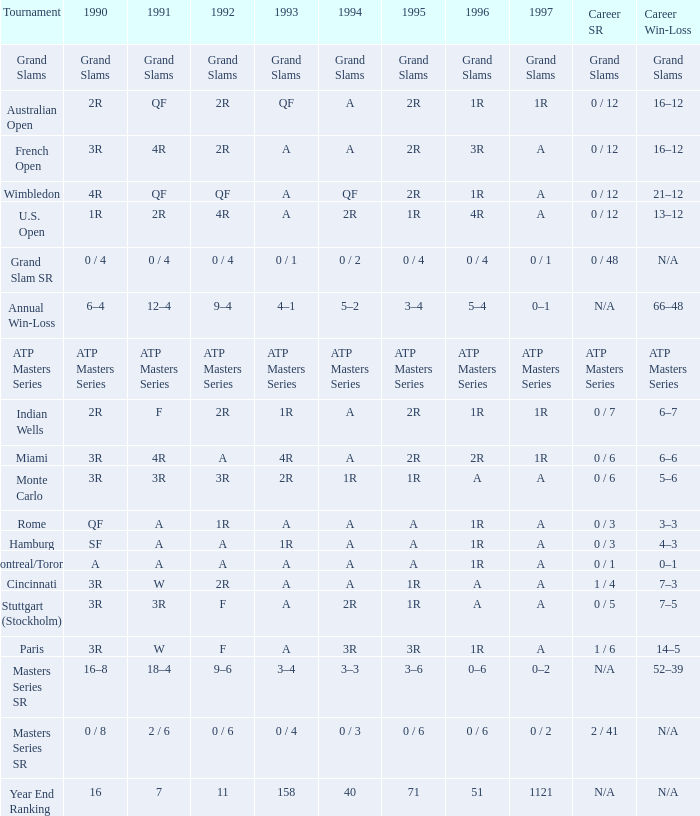When the career sr is "atp masters series," what is the meaning of tournament? ATP Masters Series. 